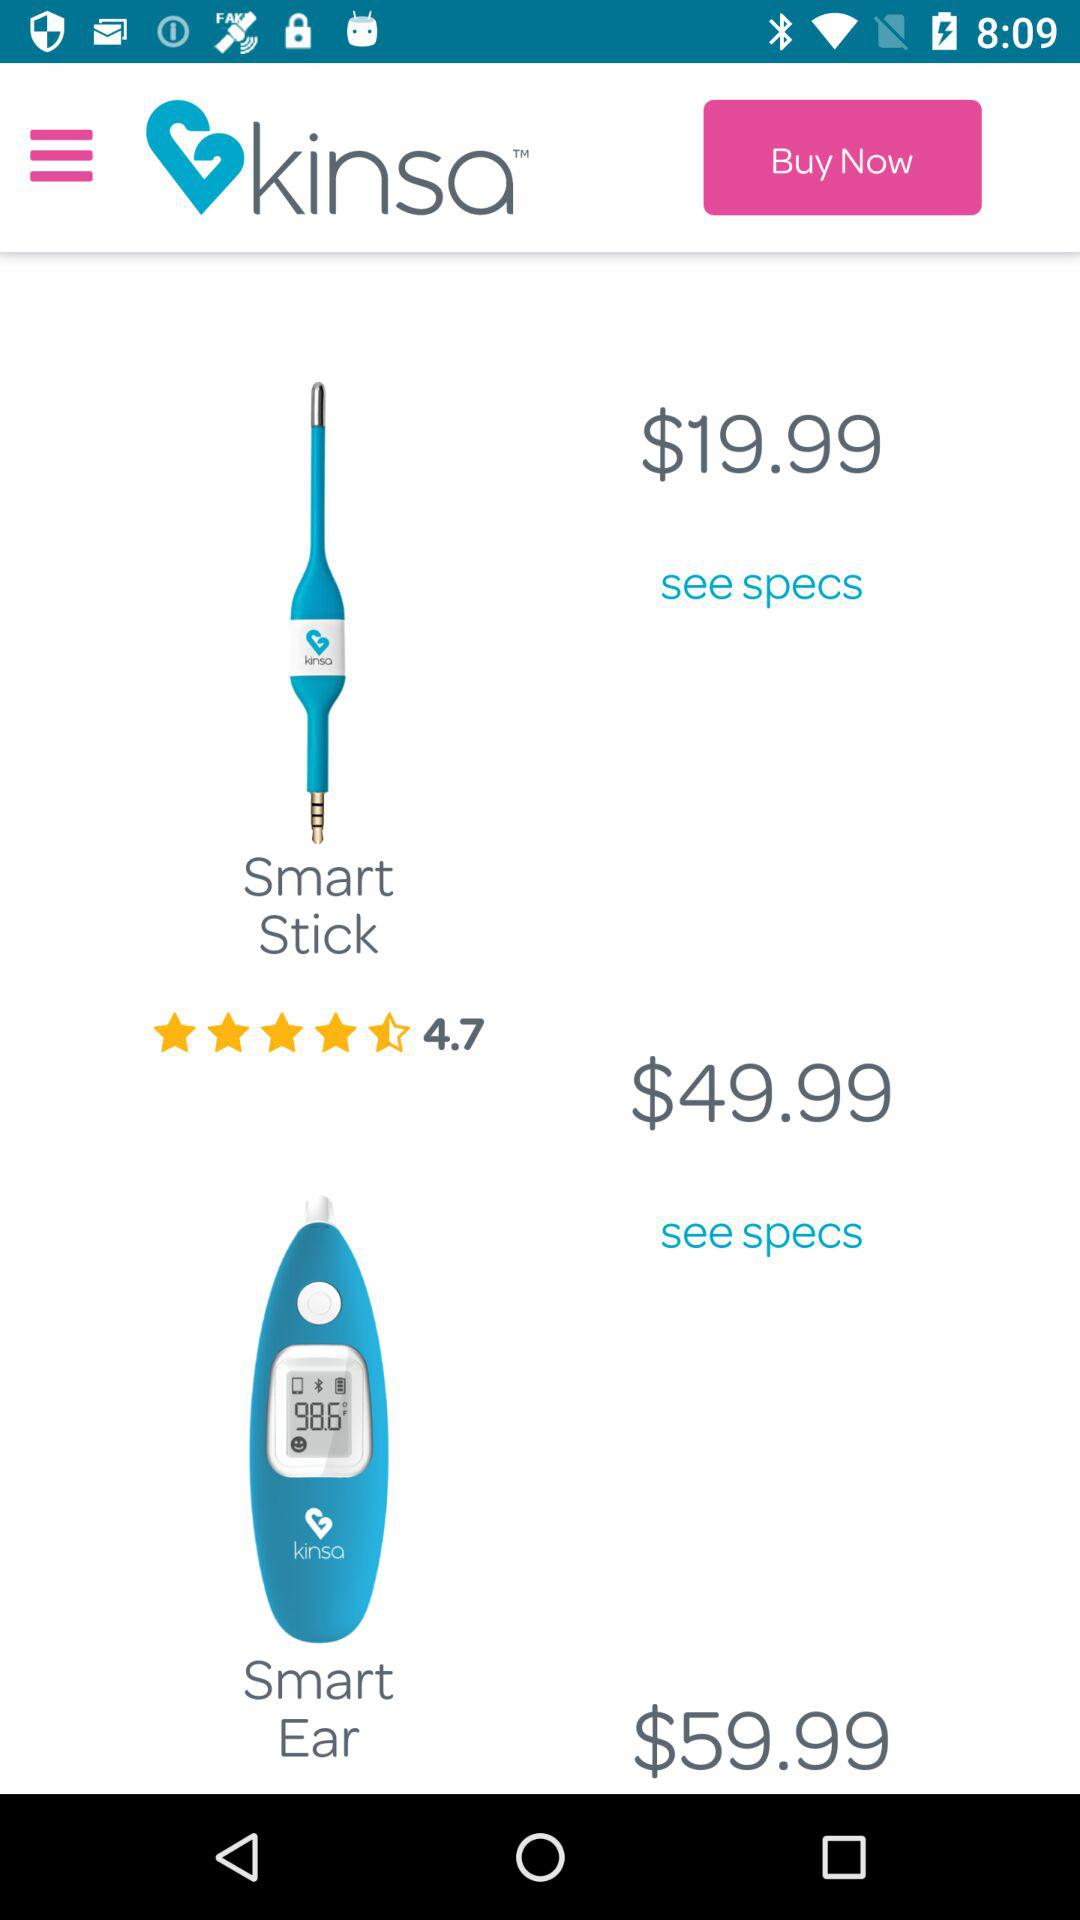What is the application name? The application name is "kinsa". 